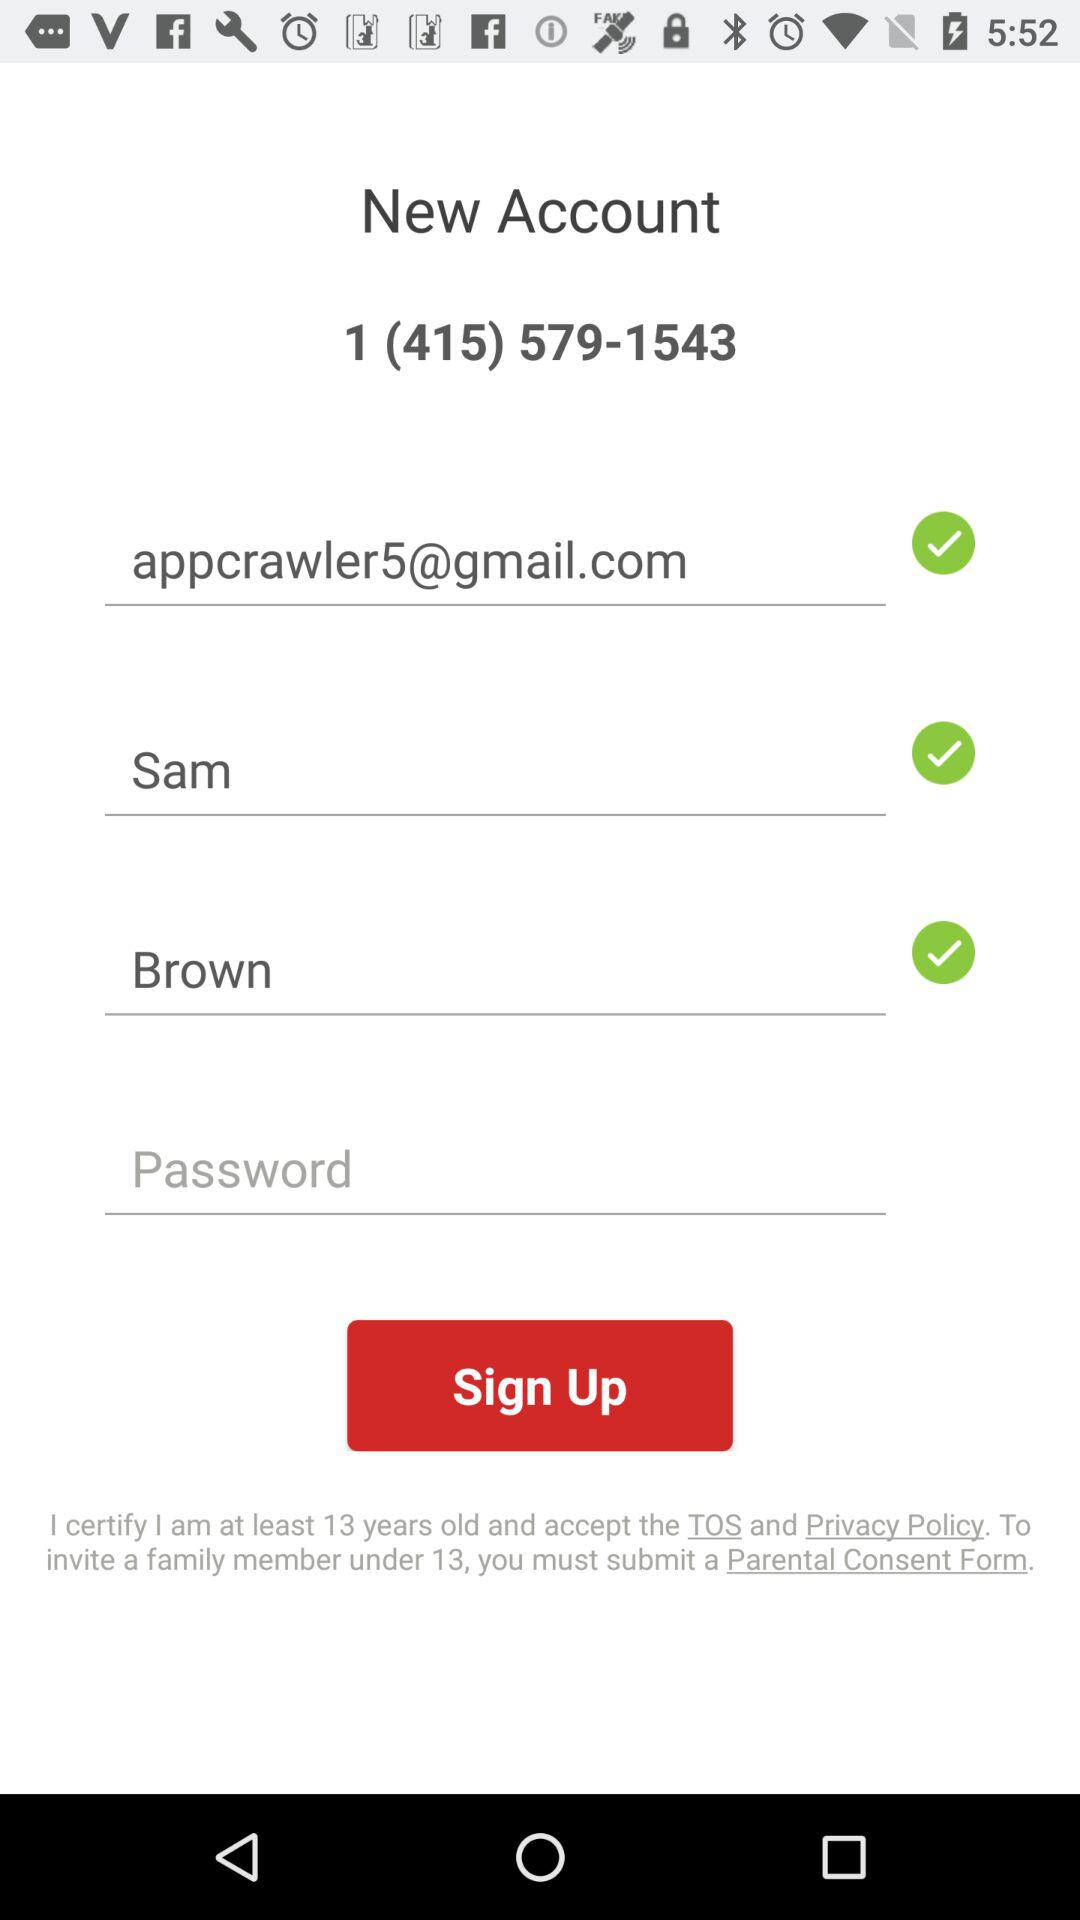What is the contact number? The contact number is 1 (415) 579-1543. 